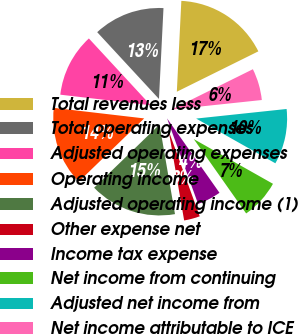<chart> <loc_0><loc_0><loc_500><loc_500><pie_chart><fcel>Total revenues less<fcel>Total operating expenses<fcel>Adjusted operating expenses<fcel>Operating income<fcel>Adjusted operating income (1)<fcel>Other expense net<fcel>Income tax expense<fcel>Net income from continuing<fcel>Adjusted net income from<fcel>Net income attributable to ICE<nl><fcel>16.89%<fcel>12.67%<fcel>11.27%<fcel>14.08%<fcel>15.49%<fcel>2.82%<fcel>4.23%<fcel>7.05%<fcel>9.86%<fcel>5.64%<nl></chart> 